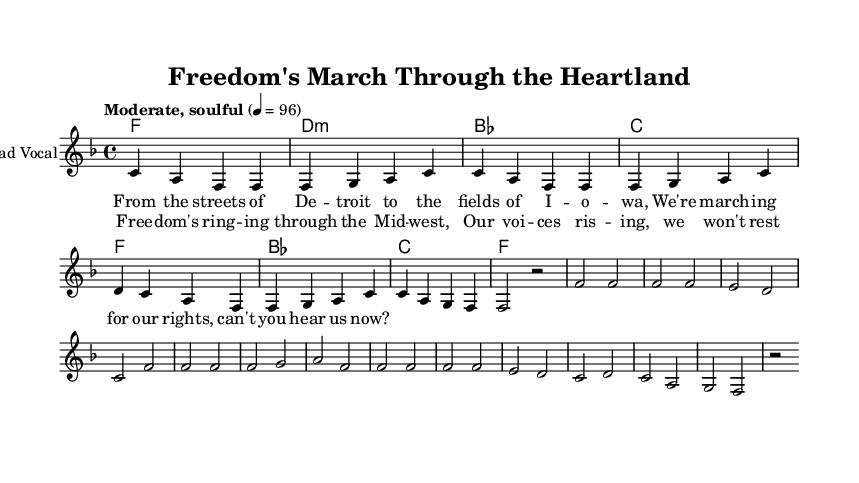What is the key signature of this music? The key signature is F major, indicated by one flat (B flat) in the key signature, which can be identified in the beginning of the sheet music.
Answer: F major What is the time signature of this music? The time signature is 4/4, which is shown at the beginning of the sheet music. This indicates that there are four beats in each measure and that the quarter note receives one beat.
Answer: 4/4 What is the tempo marking for the music? The tempo marking is "Moderate, soulful" with a tempo of 96 beats per minute, which establishes the pace at which the piece should be played.
Answer: Moderate, soulful How many measures are in the verse section? The verse section consists of four measures, as indicated by the sequence of notes and rests presented before reaching the chorus.
Answer: 4 Which notes begin the melody of the song? The melody begins with the notes C, A, and F, starting from the first note of the verse. This provides the foundation for the melodic structure.
Answer: C, A, F What is the main theme conveyed in the lyrics? The main theme conveyed in the lyrics highlights the struggle for civil rights, emphasizing unity and the call for freedom through the use of phrases like "marching for our rights."
Answer: Civil rights What are the primary chords used in the chorus? The primary chords in the chorus are F, B flat, C, and F, showing a common progression often found in rhythm and blues music.
Answer: F, B flat, C, F 